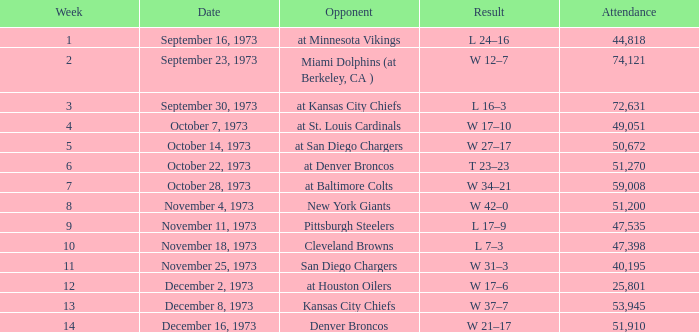What is the result later than week 13? W 21–17. 